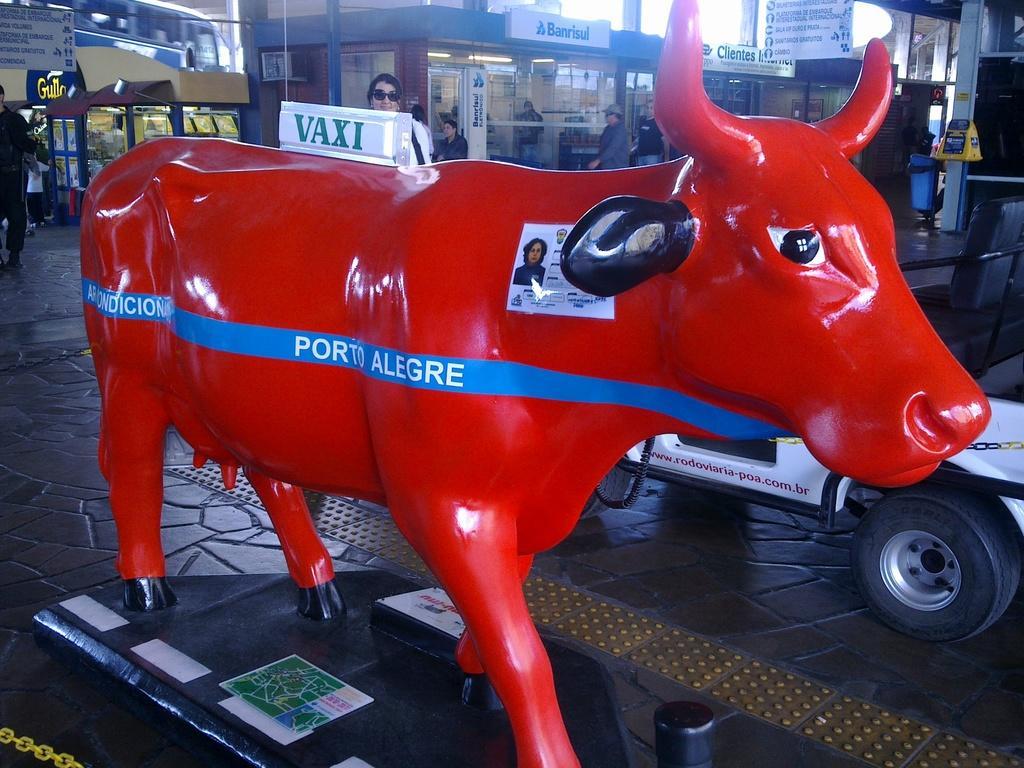In one or two sentences, can you explain what this image depicts? In this image I can see the ground, a red colored statue of an animal, few persons standing, few vehicles and few buildings. In the background I can see few boards and the sky. 